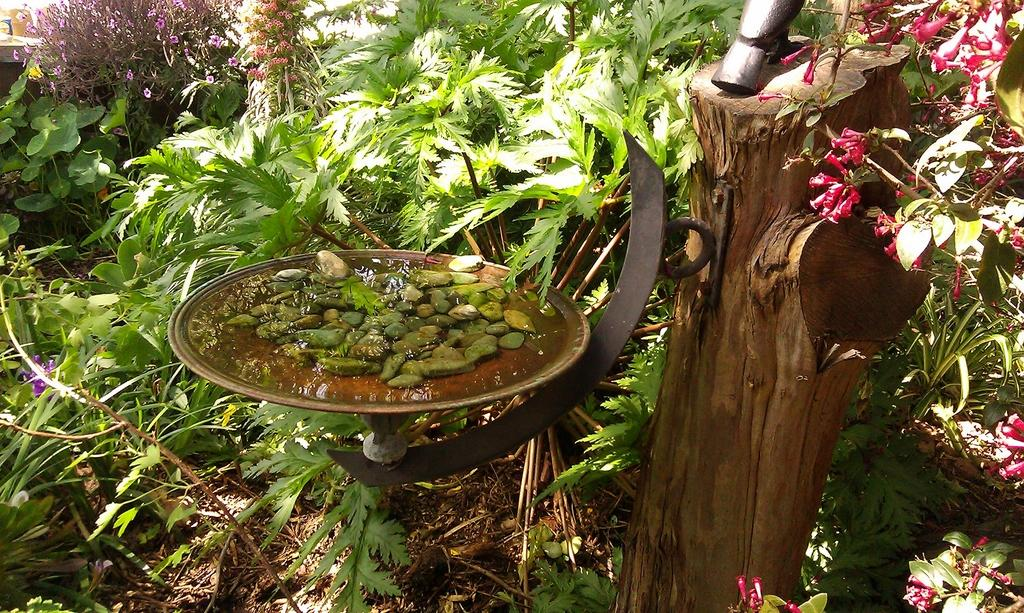What type of plants can be seen in the image? There are plants with leaves and branches in the image. What distinguishing feature do the plants have? The plants have colorful flowers. What part of the plant is visible in the image? There is a tree trunk in the image. What is the purpose of the plate filled with water in the image? The plate filled with water is likely for the plants to absorb water through their roots. What additional elements are present in the plate? Small rocks are present in the plate. What type of noise can be heard coming from the book in the image? There is no book present in the image, so no noise can be heard from a book. 